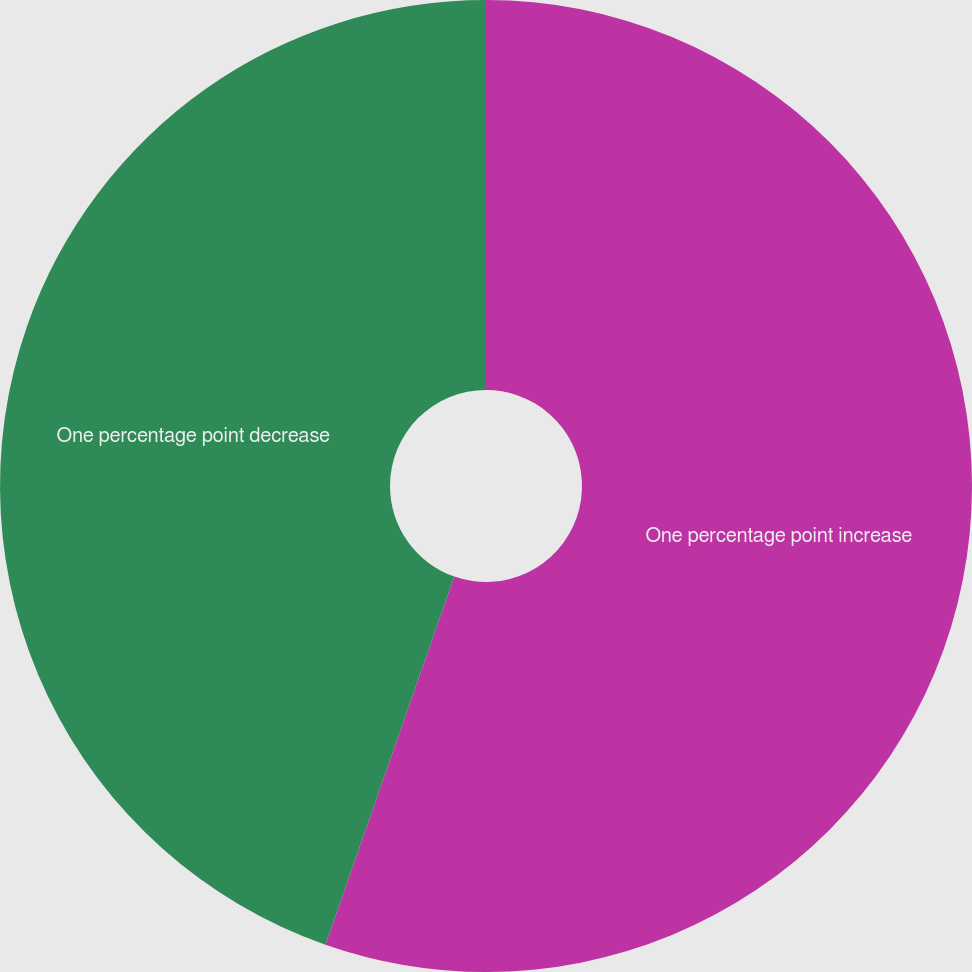<chart> <loc_0><loc_0><loc_500><loc_500><pie_chart><fcel>One percentage point increase<fcel>One percentage point decrease<nl><fcel>55.36%<fcel>44.64%<nl></chart> 